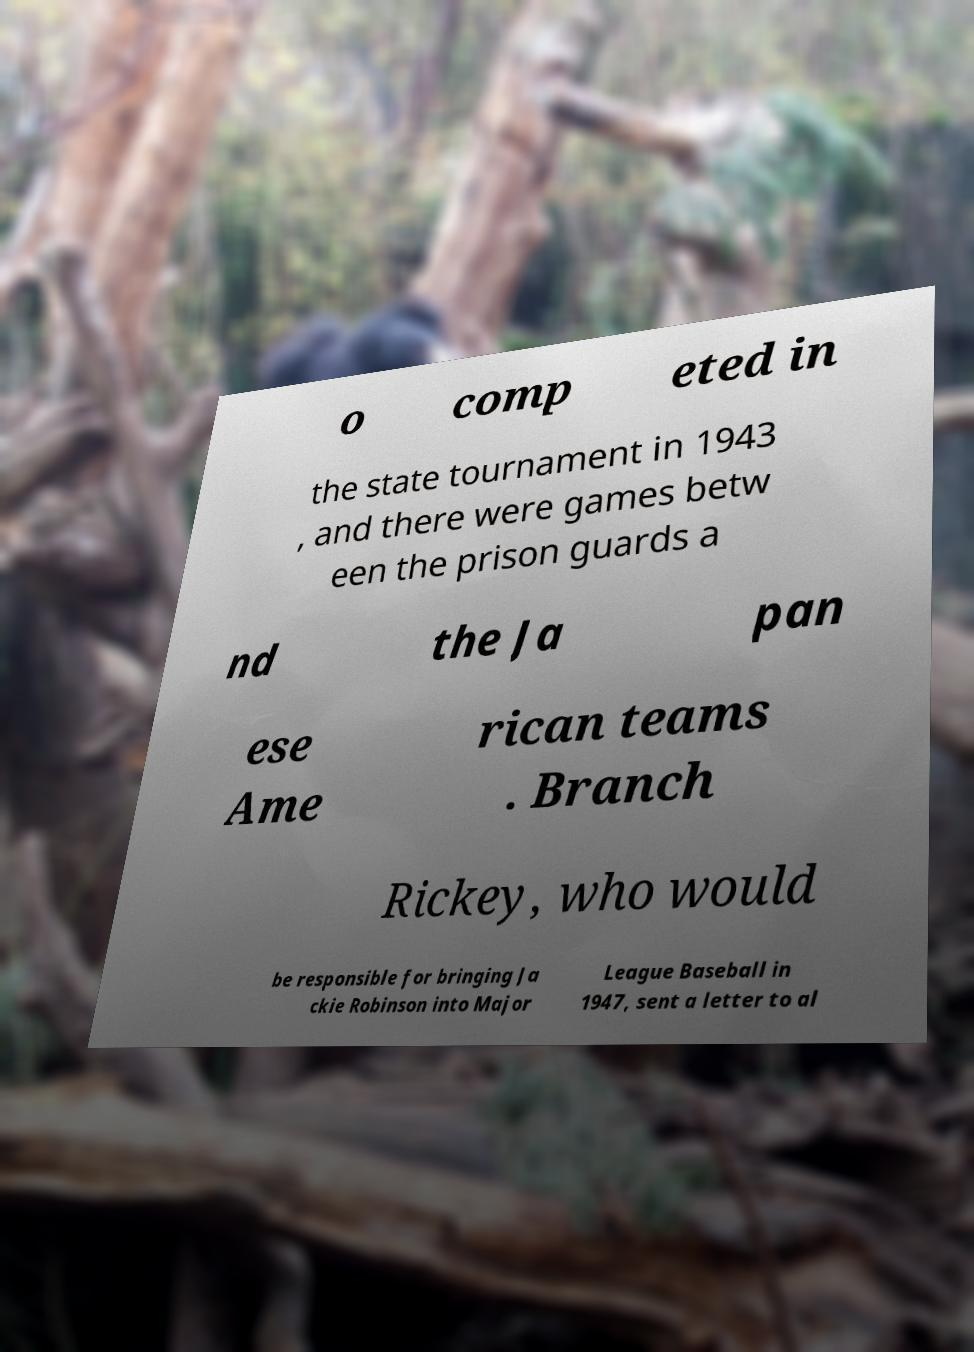Please identify and transcribe the text found in this image. o comp eted in the state tournament in 1943 , and there were games betw een the prison guards a nd the Ja pan ese Ame rican teams . Branch Rickey, who would be responsible for bringing Ja ckie Robinson into Major League Baseball in 1947, sent a letter to al 